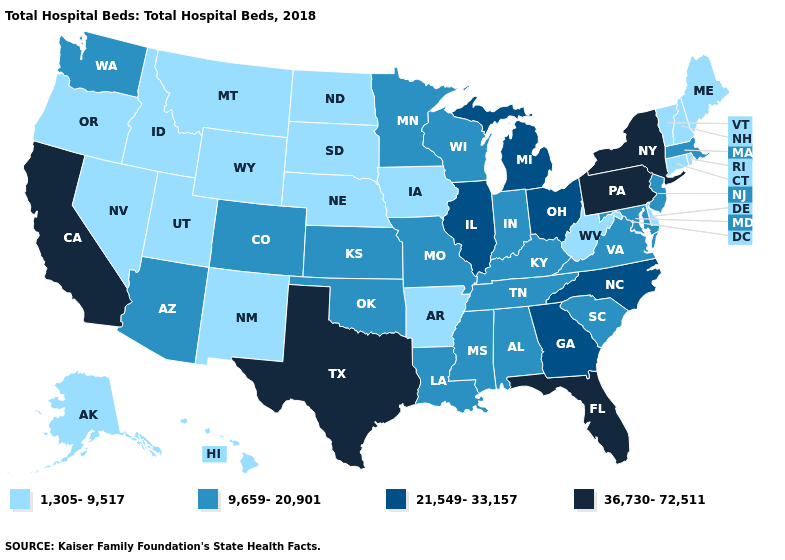Name the states that have a value in the range 1,305-9,517?
Concise answer only. Alaska, Arkansas, Connecticut, Delaware, Hawaii, Idaho, Iowa, Maine, Montana, Nebraska, Nevada, New Hampshire, New Mexico, North Dakota, Oregon, Rhode Island, South Dakota, Utah, Vermont, West Virginia, Wyoming. Which states have the lowest value in the South?
Give a very brief answer. Arkansas, Delaware, West Virginia. Which states have the lowest value in the USA?
Quick response, please. Alaska, Arkansas, Connecticut, Delaware, Hawaii, Idaho, Iowa, Maine, Montana, Nebraska, Nevada, New Hampshire, New Mexico, North Dakota, Oregon, Rhode Island, South Dakota, Utah, Vermont, West Virginia, Wyoming. Among the states that border Pennsylvania , does Delaware have the highest value?
Give a very brief answer. No. Does Florida have the highest value in the South?
Quick response, please. Yes. What is the highest value in the USA?
Write a very short answer. 36,730-72,511. Is the legend a continuous bar?
Answer briefly. No. What is the value of Texas?
Quick response, please. 36,730-72,511. Name the states that have a value in the range 36,730-72,511?
Quick response, please. California, Florida, New York, Pennsylvania, Texas. What is the lowest value in states that border Kentucky?
Answer briefly. 1,305-9,517. Name the states that have a value in the range 21,549-33,157?
Short answer required. Georgia, Illinois, Michigan, North Carolina, Ohio. Among the states that border Minnesota , does Wisconsin have the lowest value?
Be succinct. No. How many symbols are there in the legend?
Keep it brief. 4. Does Connecticut have the highest value in the Northeast?
Keep it brief. No. What is the value of New Mexico?
Write a very short answer. 1,305-9,517. 